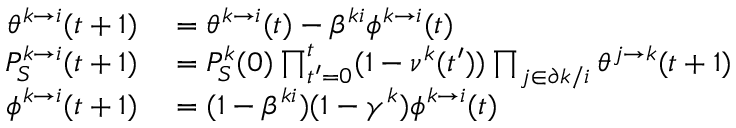Convert formula to latex. <formula><loc_0><loc_0><loc_500><loc_500>\begin{array} { r l } { \theta ^ { k \to i } ( t + 1 ) } & = \theta ^ { k \to i } ( t ) - \beta ^ { k i } \phi ^ { k \to i } ( t ) } \\ { P _ { S } ^ { k \to i } ( t + 1 ) } & = P _ { S } ^ { k } ( 0 ) \prod _ { t ^ { \prime } = 0 } ^ { t } ( 1 - \nu ^ { k } ( t ^ { \prime } ) ) \prod _ { j \in \partial k / i } \theta ^ { j \to k } ( t + 1 ) } \\ { \phi ^ { k \to i } ( t + 1 ) } & = ( 1 - \beta ^ { k i } ) ( 1 - \gamma ^ { k } ) \phi ^ { k \to i } ( t ) } \end{array}</formula> 